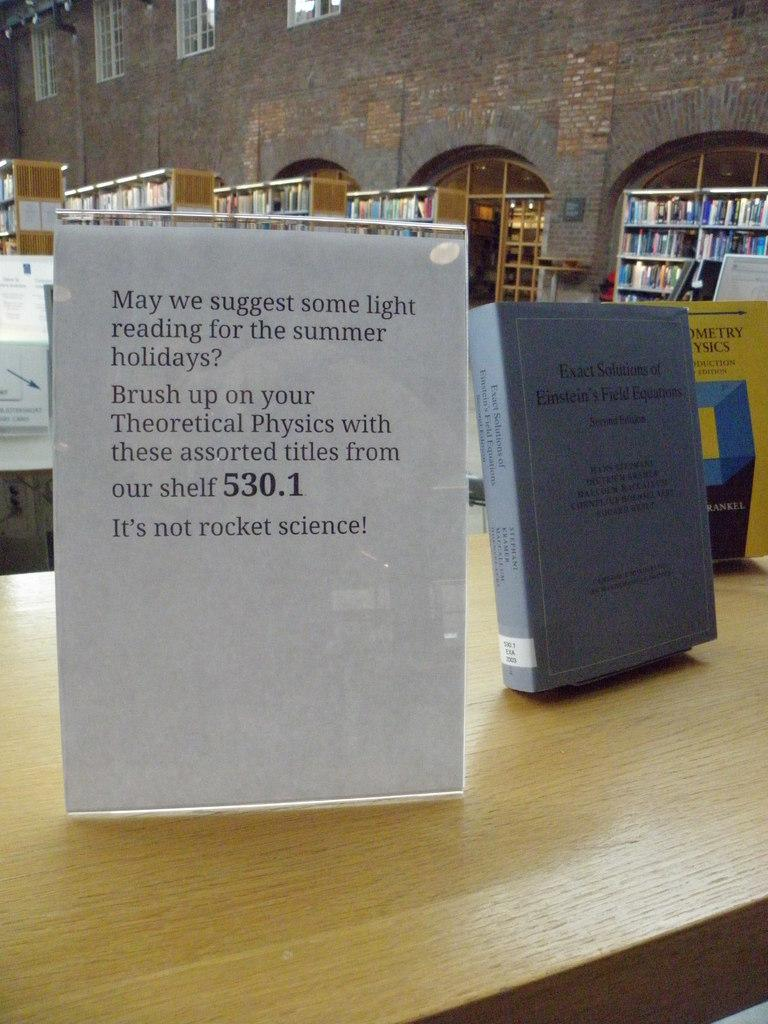What type of structure is visible in the image? There is a building in the image. What is unique about the cracks in the building? The cracks in the building are filled with books. What furniture can be seen in the image? There are tables in the image. What type of decorations are present in the image? There are posters in the image. What allows natural light to enter the building? There are windows in the image. What type of popcorn is being served at the building's roof in the image? There is no popcorn or roof present in the image; it only shows a building with cracks filled with books, tables, posters, and windows. 